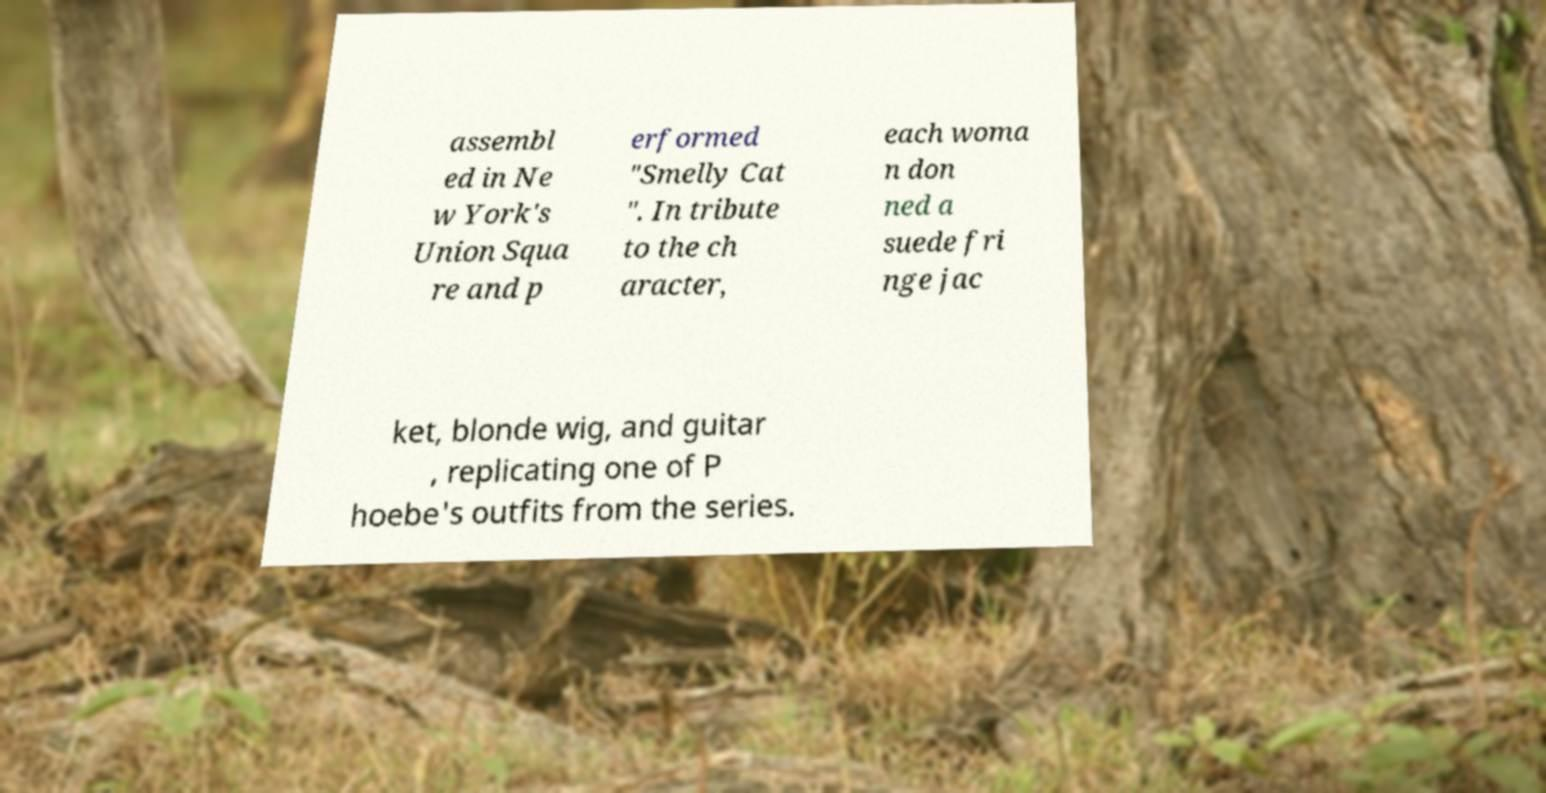Could you assist in decoding the text presented in this image and type it out clearly? assembl ed in Ne w York's Union Squa re and p erformed "Smelly Cat ". In tribute to the ch aracter, each woma n don ned a suede fri nge jac ket, blonde wig, and guitar , replicating one of P hoebe's outfits from the series. 